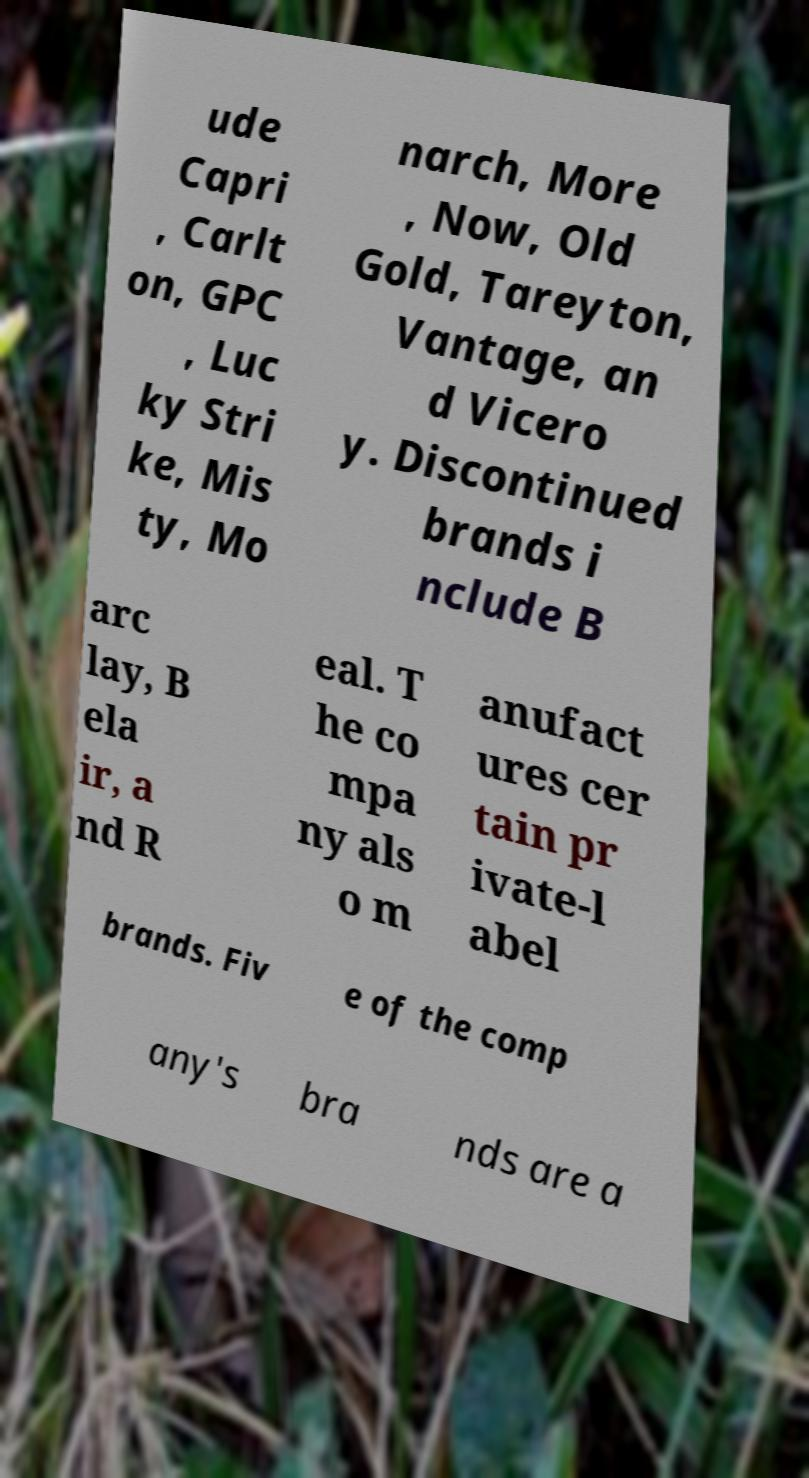Please read and relay the text visible in this image. What does it say? ude Capri , Carlt on, GPC , Luc ky Stri ke, Mis ty, Mo narch, More , Now, Old Gold, Tareyton, Vantage, an d Vicero y. Discontinued brands i nclude B arc lay, B ela ir, a nd R eal. T he co mpa ny als o m anufact ures cer tain pr ivate-l abel brands. Fiv e of the comp any's bra nds are a 